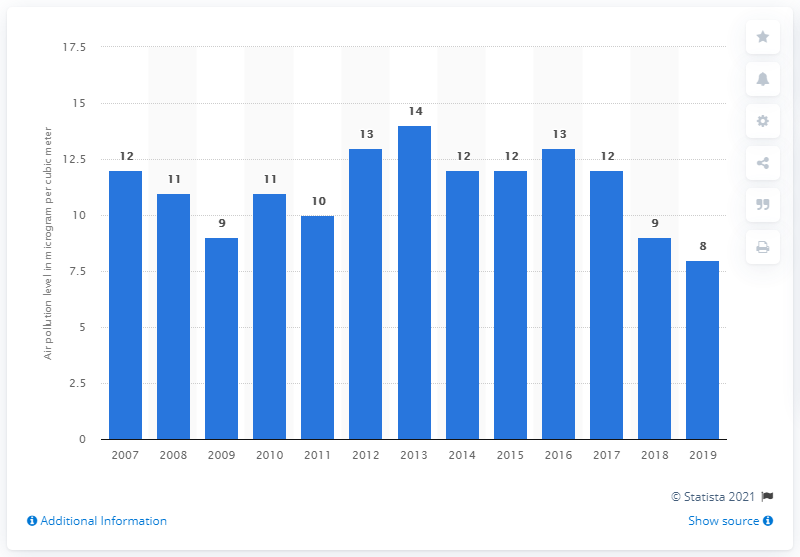Specify some key components in this picture. The level of sulfur dioxide air pollution in Singapore has been decreasing since 2016. 